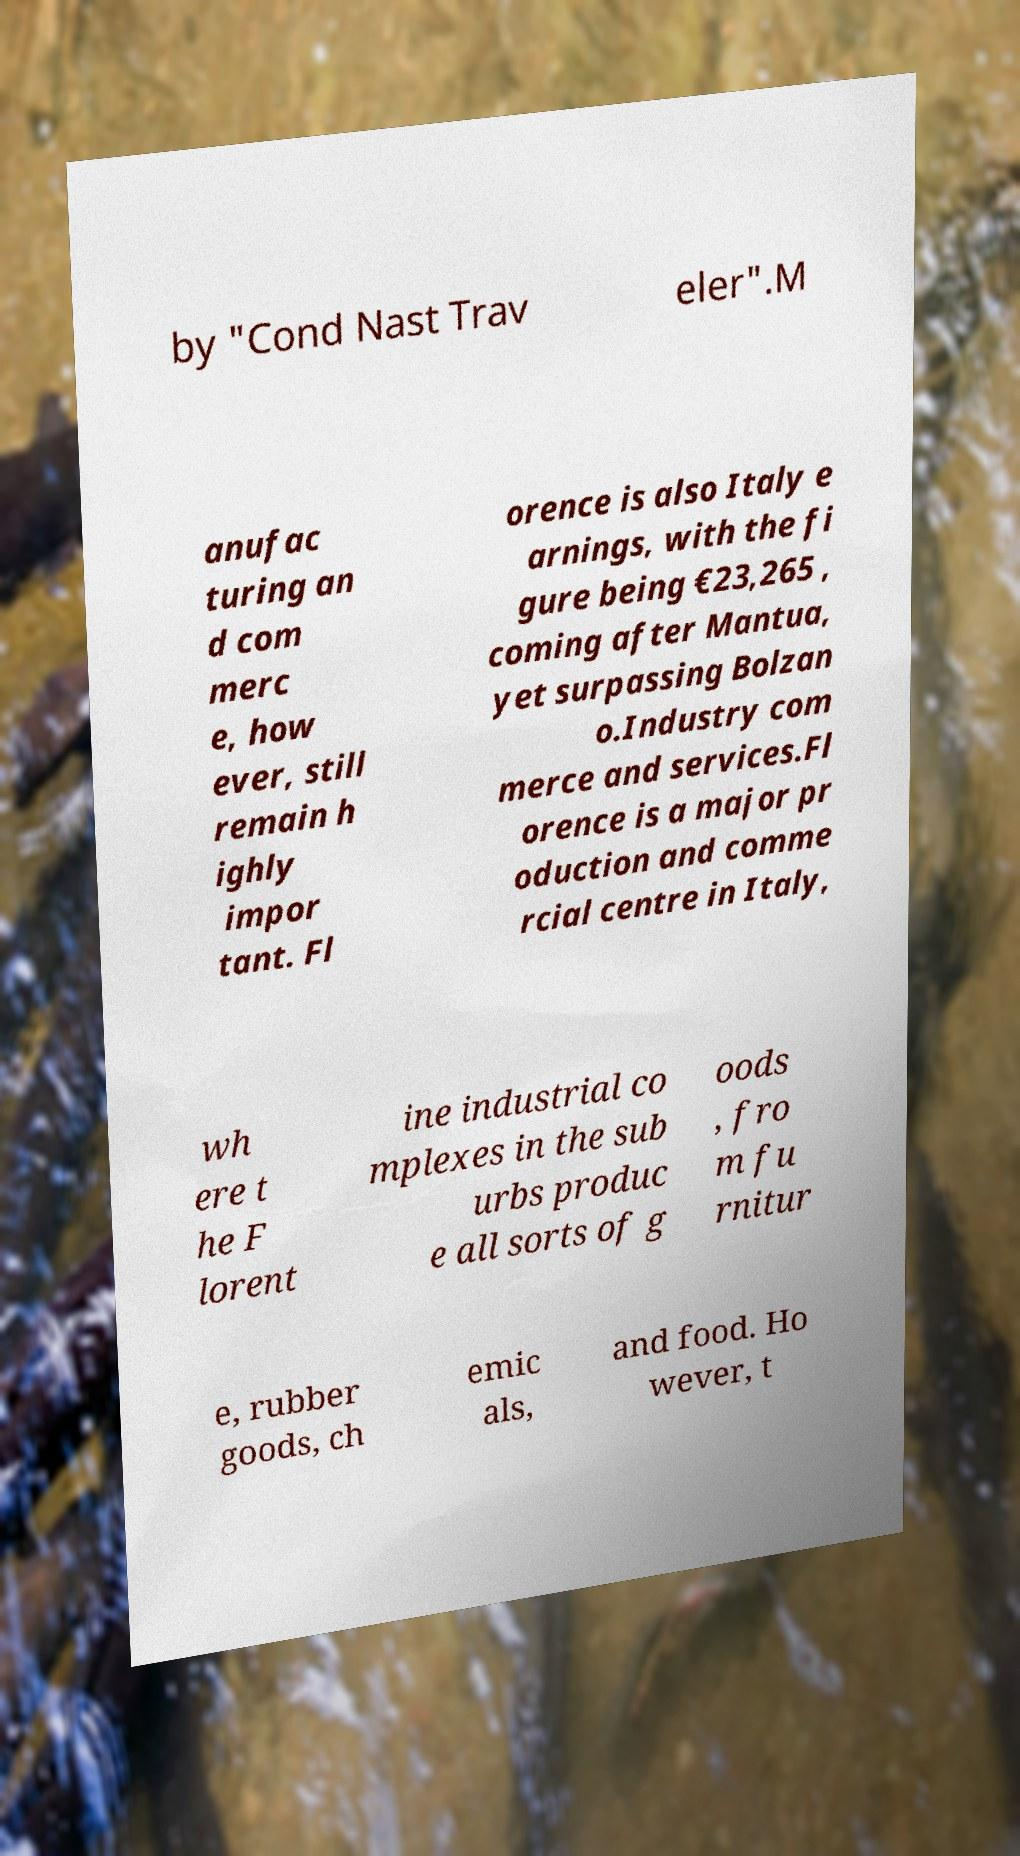I need the written content from this picture converted into text. Can you do that? by "Cond Nast Trav eler".M anufac turing an d com merc e, how ever, still remain h ighly impor tant. Fl orence is also Italy e arnings, with the fi gure being €23,265 , coming after Mantua, yet surpassing Bolzan o.Industry com merce and services.Fl orence is a major pr oduction and comme rcial centre in Italy, wh ere t he F lorent ine industrial co mplexes in the sub urbs produc e all sorts of g oods , fro m fu rnitur e, rubber goods, ch emic als, and food. Ho wever, t 